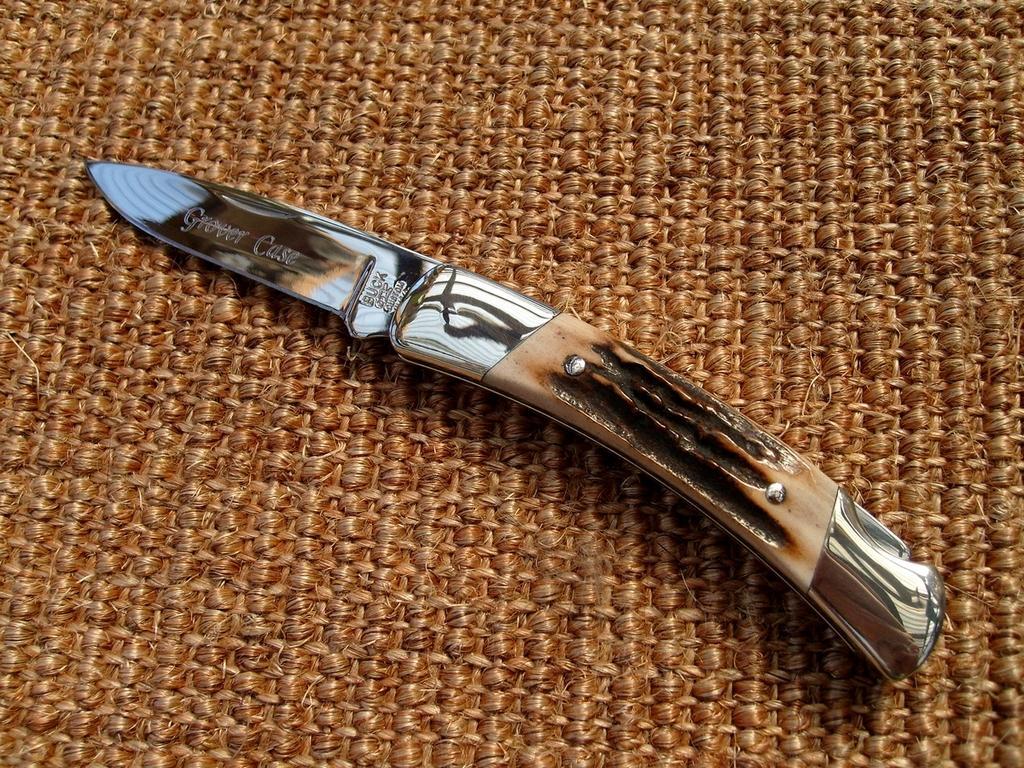Could you give a brief overview of what you see in this image? In this image we can see a knife on an object. 